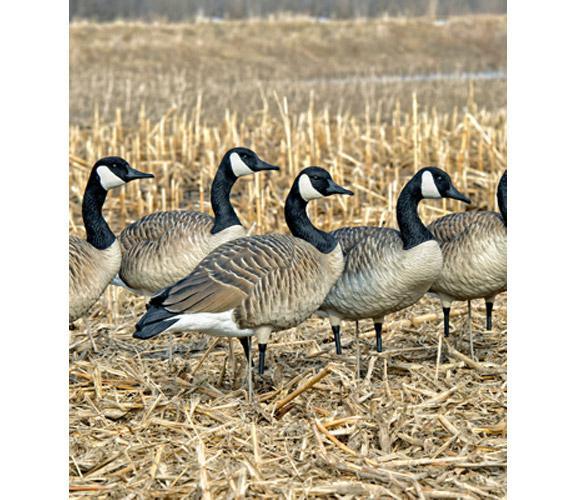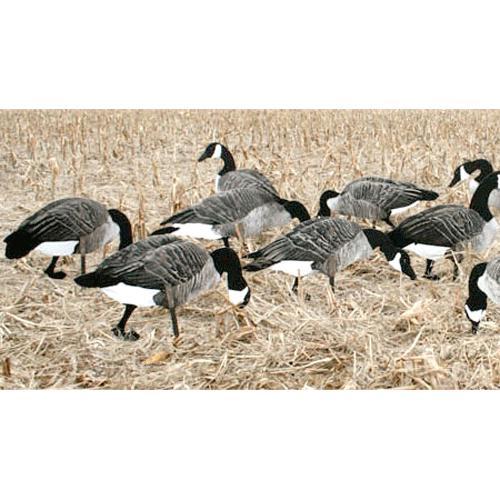The first image is the image on the left, the second image is the image on the right. Analyze the images presented: Is the assertion "There are 18 or more Canadian Geese in open fields." valid? Answer yes or no. No. 